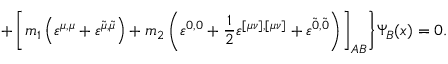<formula> <loc_0><loc_0><loc_500><loc_500>+ \left [ m _ { 1 } \left ( \varepsilon ^ { \mu , \mu } + \varepsilon ^ { \widetilde { \mu } , \widetilde { \mu } } \right ) + m _ { 2 } \left ( \varepsilon ^ { 0 , 0 } + \frac { 1 } { 2 } \varepsilon ^ { [ \mu \nu ] , [ \mu \nu ] } + \varepsilon ^ { \widetilde { 0 } , \widetilde { 0 } } \right ) \right ] _ { A B } \Big \} \Psi _ { B } ( x ) = 0 .</formula> 